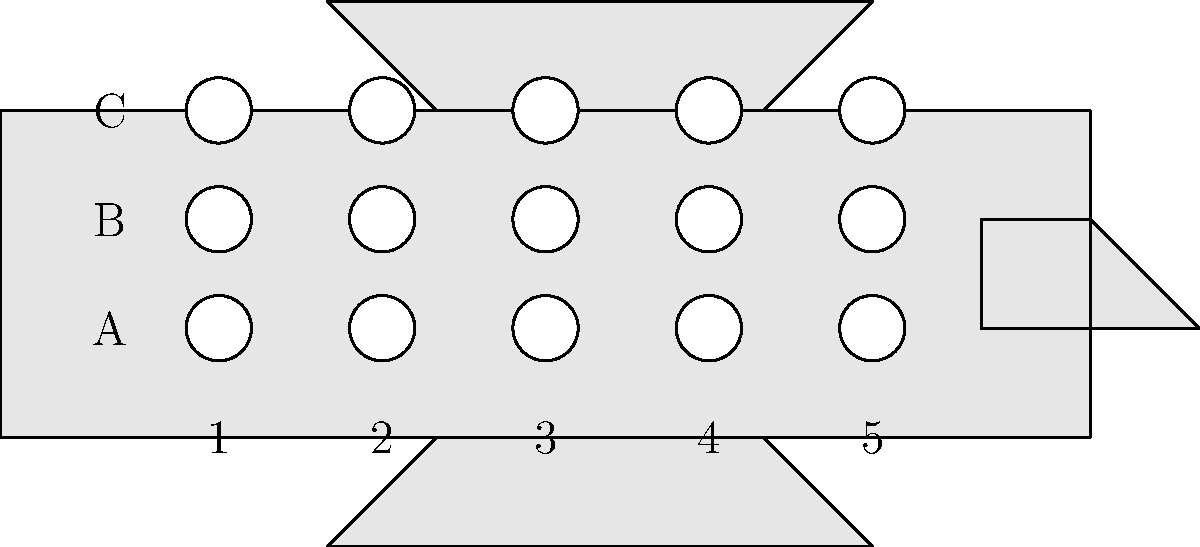In your private jet booking app, you're optimizing seating arrangements for a luxury jet with 5 rows and 3 seats per row (A, B, C). If a group of 6 VIP clients must be seated together with the following constraints:
1. Two clients must have aisle seats (B)
2. One client prefers a window seat (A or C)
3. The remaining three can sit anywhere

What is the minimum number of rows needed to accommodate this group while satisfying all constraints? Let's approach this step-by-step:

1. We have 6 VIP clients to seat with specific constraints.

2. The jet has 3 seats per row: A (window), B (aisle), and C (window).

3. Let's break down the seating requirements:
   - 2 clients need aisle seats (B)
   - 1 client needs a window seat (A or C)
   - 3 clients can sit anywhere

4. To minimize the number of rows, we need to optimize the seating arrangement:
   - Row 1: A (window preference), B (aisle requirement), C (flexible)
   - Row 2: A (flexible), B (aisle requirement), C (flexible)

5. This arrangement satisfies all constraints:
   - 2 aisle seats (B) are filled
   - 1 window seat (A) is filled for the client with that preference
   - The remaining 3 flexible clients are accommodated

6. By using this arrangement, we can seat all 6 VIP clients in just 2 rows.

Therefore, the minimum number of rows needed is 2.
Answer: 2 rows 